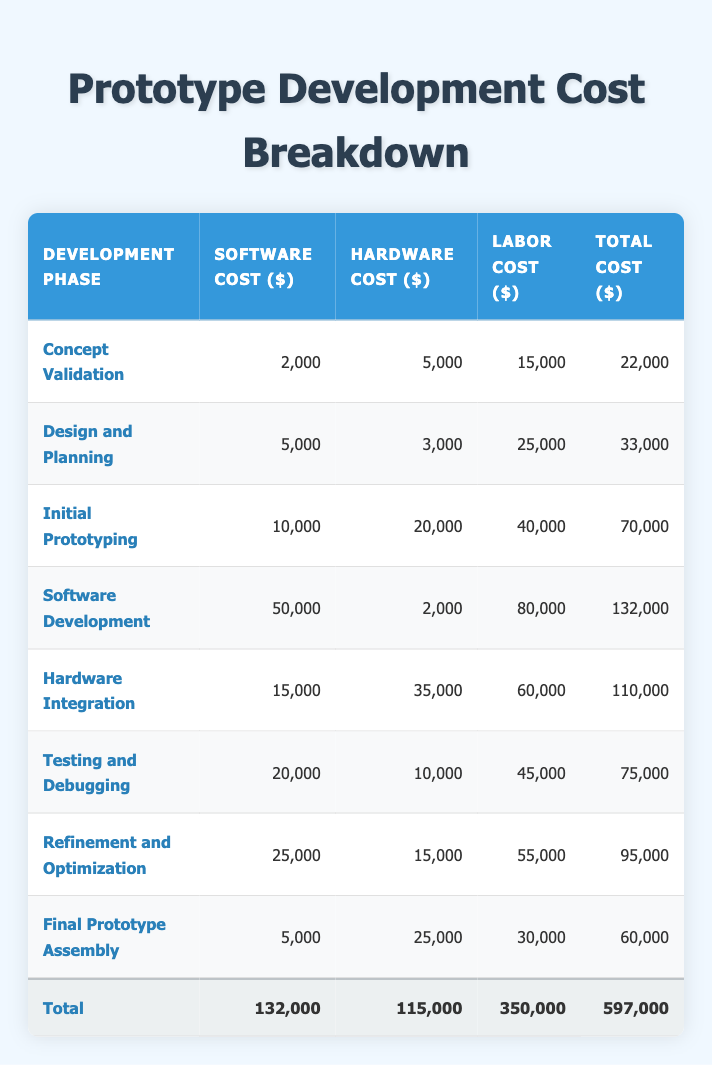What is the total cost of the initial prototyping phase? The total cost of the initial prototyping phase is listed in the table under the "Total Cost ($)" column. For this phase, it is $70,000.
Answer: 70000 Which development phase has the highest software cost? The development phase with the highest software cost is the "Software Development" phase, where the cost is $50,000.
Answer: 50000 What is the combined labor cost for the testing and debugging and final prototype assembly phases? To find the combined labor cost, we add the labor costs of the "Testing and Debugging" phase ($45,000) and the "Final Prototype Assembly" phase ($30,000). So, $45,000 + $30,000 = $75,000.
Answer: 75000 Is the hardware cost of the concept validation phase greater than the total cost of the design and planning phase? The hardware cost for the concept validation phase is $5,000 and the total cost for the design and planning phase is $33,000. Since $5,000 is less than $33,000, the statement is false.
Answer: No What is the average hardware cost across all development phases? To find the average hardware cost, we sum all hardware costs: $5,000 + $3,000 + $20,000 + $2,000 + $35,000 + $10,000 + $15,000 + $25,000 = $110,000. Then, dividing by the number of phases (8), we get $110,000 / 8 = $13,750.
Answer: 13750 Which development phase costs the least in total? By examining the total cost column, the "Concept Validation" phase has the lowest total cost at $22,000.
Answer: 22000 What is the difference in total cost between hardware integration and software development phases? The total cost for the hardware integration phase is $110,000 and for the software development phase is $132,000. To find the difference, we subtract: $132,000 - $110,000 = $22,000.
Answer: 22000 Are more resources allocated to software development compared to refinement and optimization phases in total? The total cost for the software development phase is $132,000 and for the refinement and optimization phase, it is $95,000. Since $132,000 is greater than $95,000, the statement is true.
Answer: Yes 